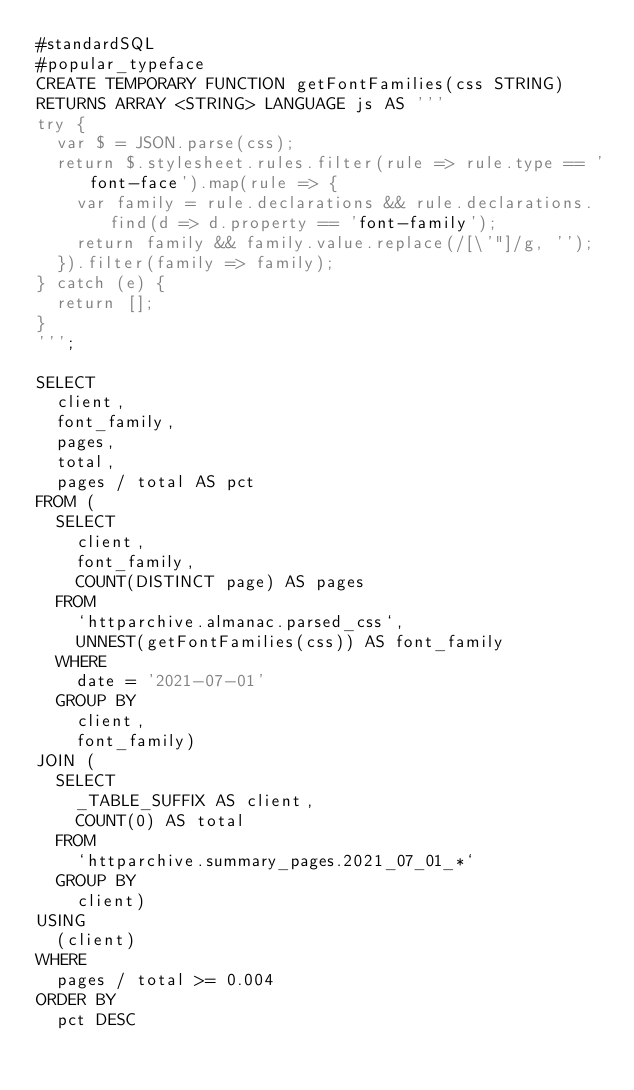Convert code to text. <code><loc_0><loc_0><loc_500><loc_500><_SQL_>#standardSQL
#popular_typeface
CREATE TEMPORARY FUNCTION getFontFamilies(css STRING)
RETURNS ARRAY <STRING> LANGUAGE js AS '''
try {
  var $ = JSON.parse(css);
  return $.stylesheet.rules.filter(rule => rule.type == 'font-face').map(rule => {
    var family = rule.declarations && rule.declarations.find(d => d.property == 'font-family');
    return family && family.value.replace(/[\'"]/g, '');
  }).filter(family => family);
} catch (e) {
  return [];
}
''';

SELECT
  client,
  font_family,
  pages,
  total,
  pages / total AS pct
FROM (
  SELECT
    client,
    font_family,
    COUNT(DISTINCT page) AS pages
  FROM
    `httparchive.almanac.parsed_css`,
    UNNEST(getFontFamilies(css)) AS font_family
  WHERE
    date = '2021-07-01'
  GROUP BY
    client,
    font_family)
JOIN (
  SELECT
    _TABLE_SUFFIX AS client,
    COUNT(0) AS total
  FROM
    `httparchive.summary_pages.2021_07_01_*`
  GROUP BY
    client)
USING
  (client)
WHERE
  pages / total >= 0.004
ORDER BY
  pct DESC
</code> 